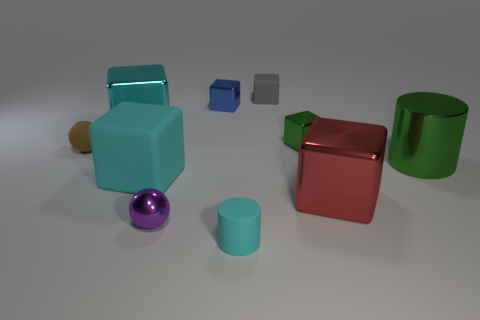What number of blue blocks are right of the big shiny cube in front of the large cyan shiny block? In the image, there are neither blue blocks to the right of the big shiny cube nor in front of the large cyan shiny block, therefore the number of blue blocks in that specified location is zero. 